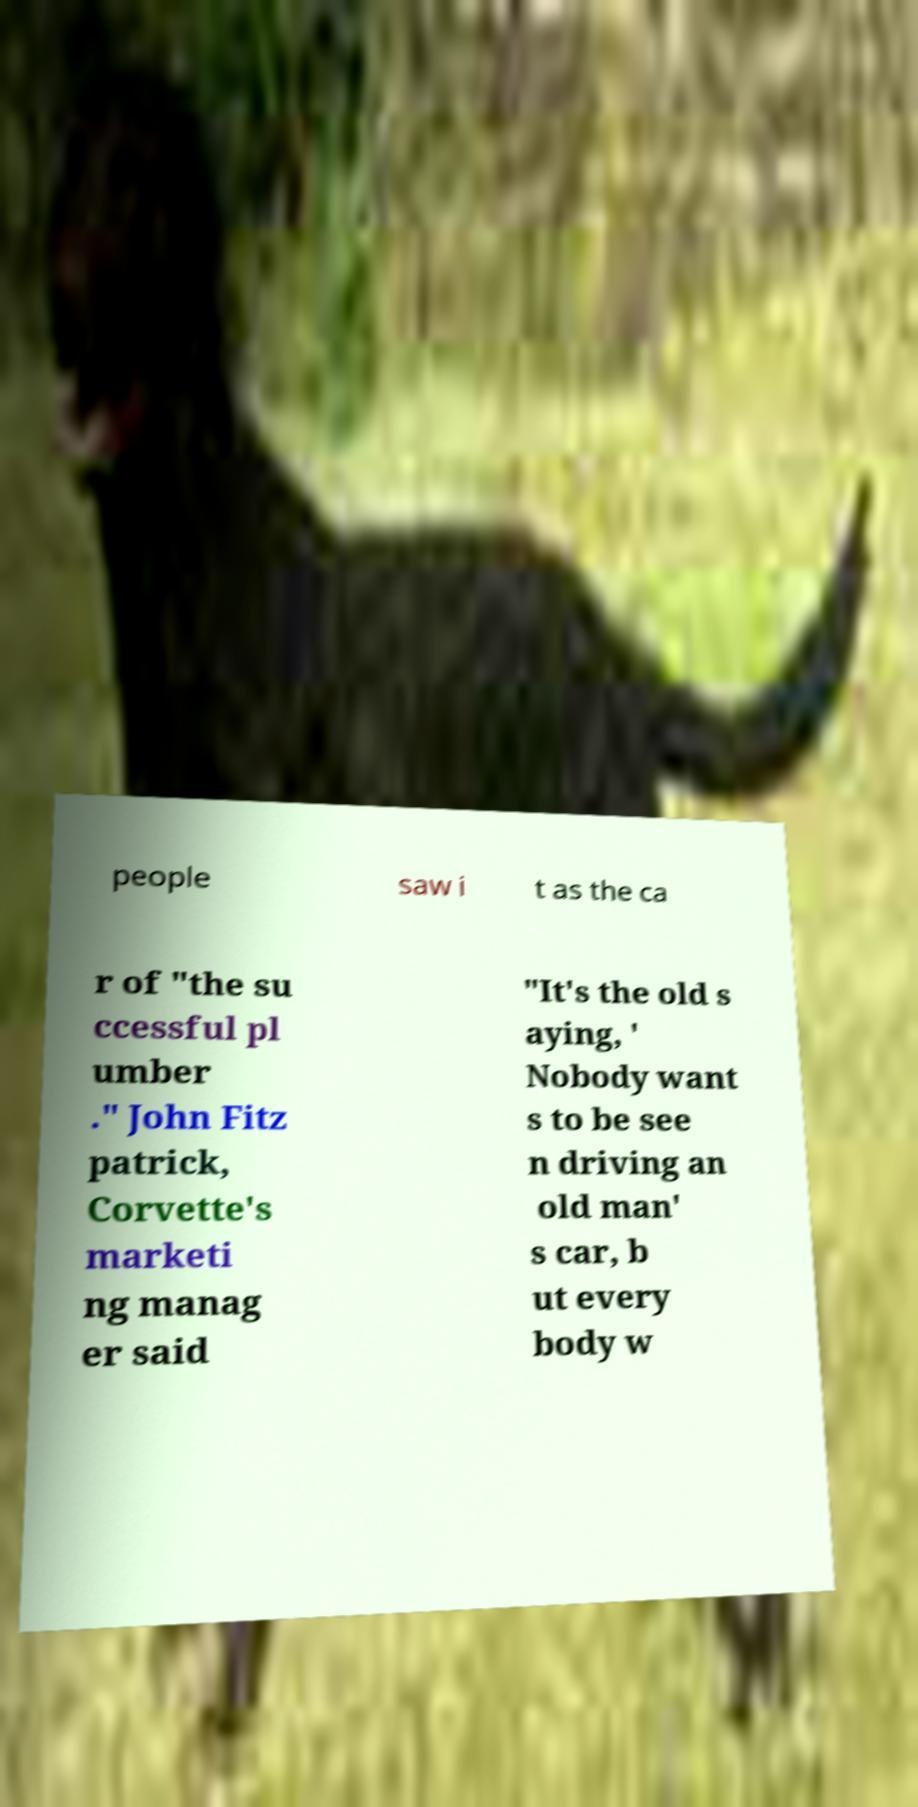Can you read and provide the text displayed in the image?This photo seems to have some interesting text. Can you extract and type it out for me? people saw i t as the ca r of "the su ccessful pl umber ." John Fitz patrick, Corvette's marketi ng manag er said "It's the old s aying, ' Nobody want s to be see n driving an old man' s car, b ut every body w 